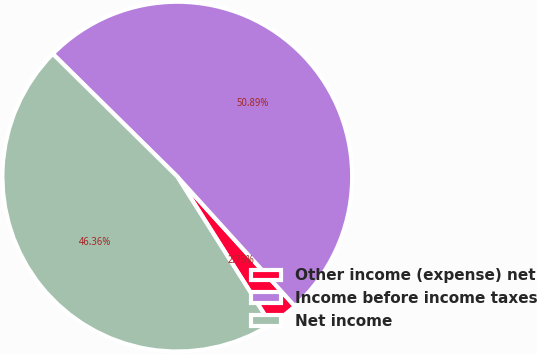Convert chart to OTSL. <chart><loc_0><loc_0><loc_500><loc_500><pie_chart><fcel>Other income (expense) net<fcel>Income before income taxes<fcel>Net income<nl><fcel>2.75%<fcel>50.88%<fcel>46.36%<nl></chart> 